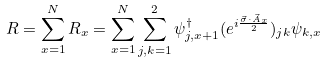Convert formula to latex. <formula><loc_0><loc_0><loc_500><loc_500>R = \sum _ { x = 1 } ^ { N } R _ { x } = \sum _ { x = 1 } ^ { N } \sum _ { j , k = 1 } ^ { 2 } \psi _ { j , x + 1 } ^ { \dag } ( e ^ { i \frac { { \vec { \sigma } } \cdot { \vec { A } } _ { x } } { 2 } } ) _ { j k } \psi _ { k , x }</formula> 